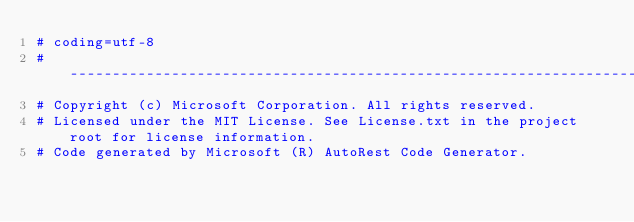Convert code to text. <code><loc_0><loc_0><loc_500><loc_500><_Python_># coding=utf-8
# --------------------------------------------------------------------------
# Copyright (c) Microsoft Corporation. All rights reserved.
# Licensed under the MIT License. See License.txt in the project root for license information.
# Code generated by Microsoft (R) AutoRest Code Generator.</code> 